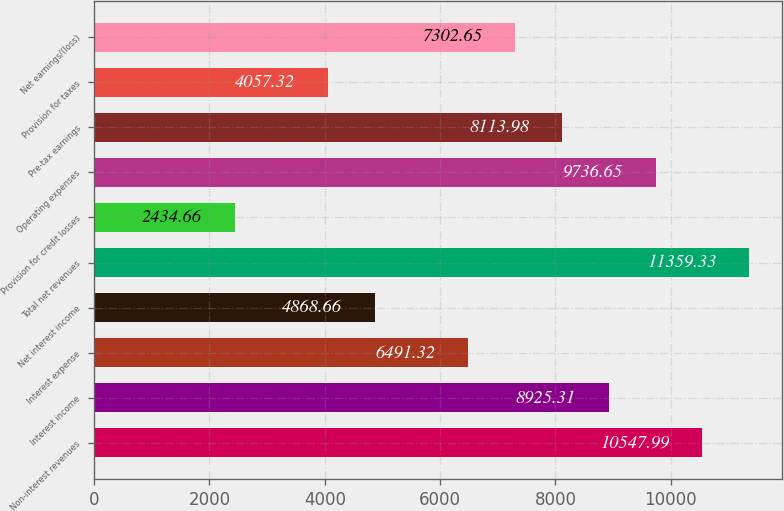Convert chart to OTSL. <chart><loc_0><loc_0><loc_500><loc_500><bar_chart><fcel>Non-interest revenues<fcel>Interest income<fcel>Interest expense<fcel>Net interest income<fcel>Total net revenues<fcel>Provision for credit losses<fcel>Operating expenses<fcel>Pre-tax earnings<fcel>Provision for taxes<fcel>Net earnings/(loss)<nl><fcel>10548<fcel>8925.31<fcel>6491.32<fcel>4868.66<fcel>11359.3<fcel>2434.66<fcel>9736.65<fcel>8113.98<fcel>4057.32<fcel>7302.65<nl></chart> 